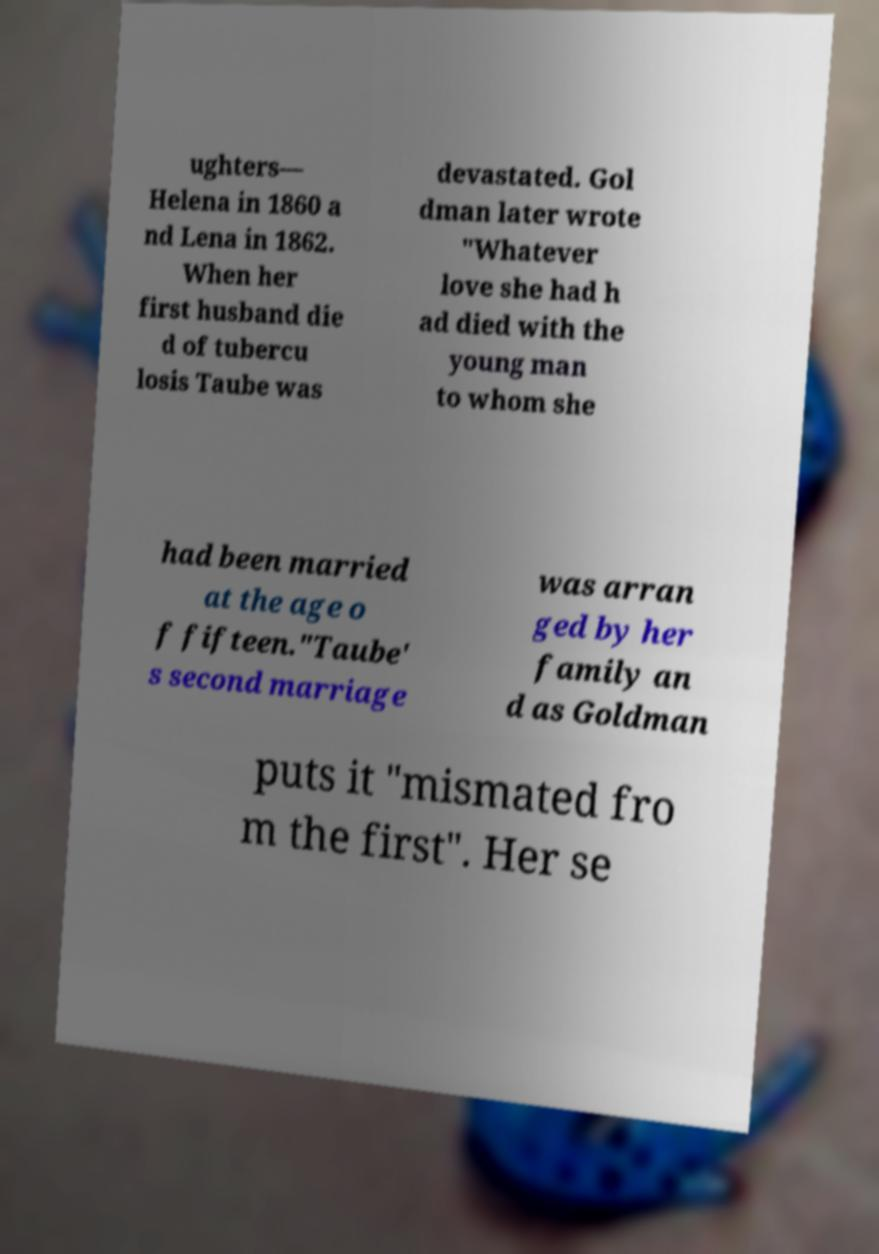For documentation purposes, I need the text within this image transcribed. Could you provide that? ughters— Helena in 1860 a nd Lena in 1862. When her first husband die d of tubercu losis Taube was devastated. Gol dman later wrote "Whatever love she had h ad died with the young man to whom she had been married at the age o f fifteen."Taube' s second marriage was arran ged by her family an d as Goldman puts it "mismated fro m the first". Her se 